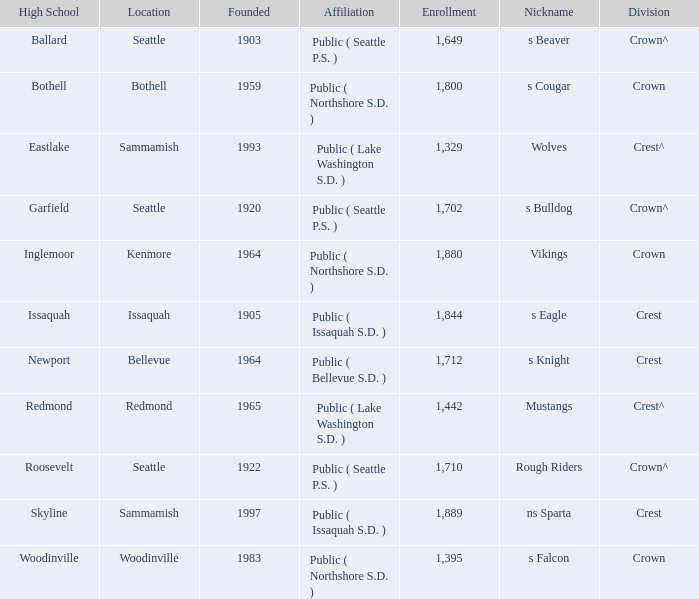What is the affiliation of a high school in Issaquah that was founded in less than 1965? Public ( Issaquah S.D. ). 